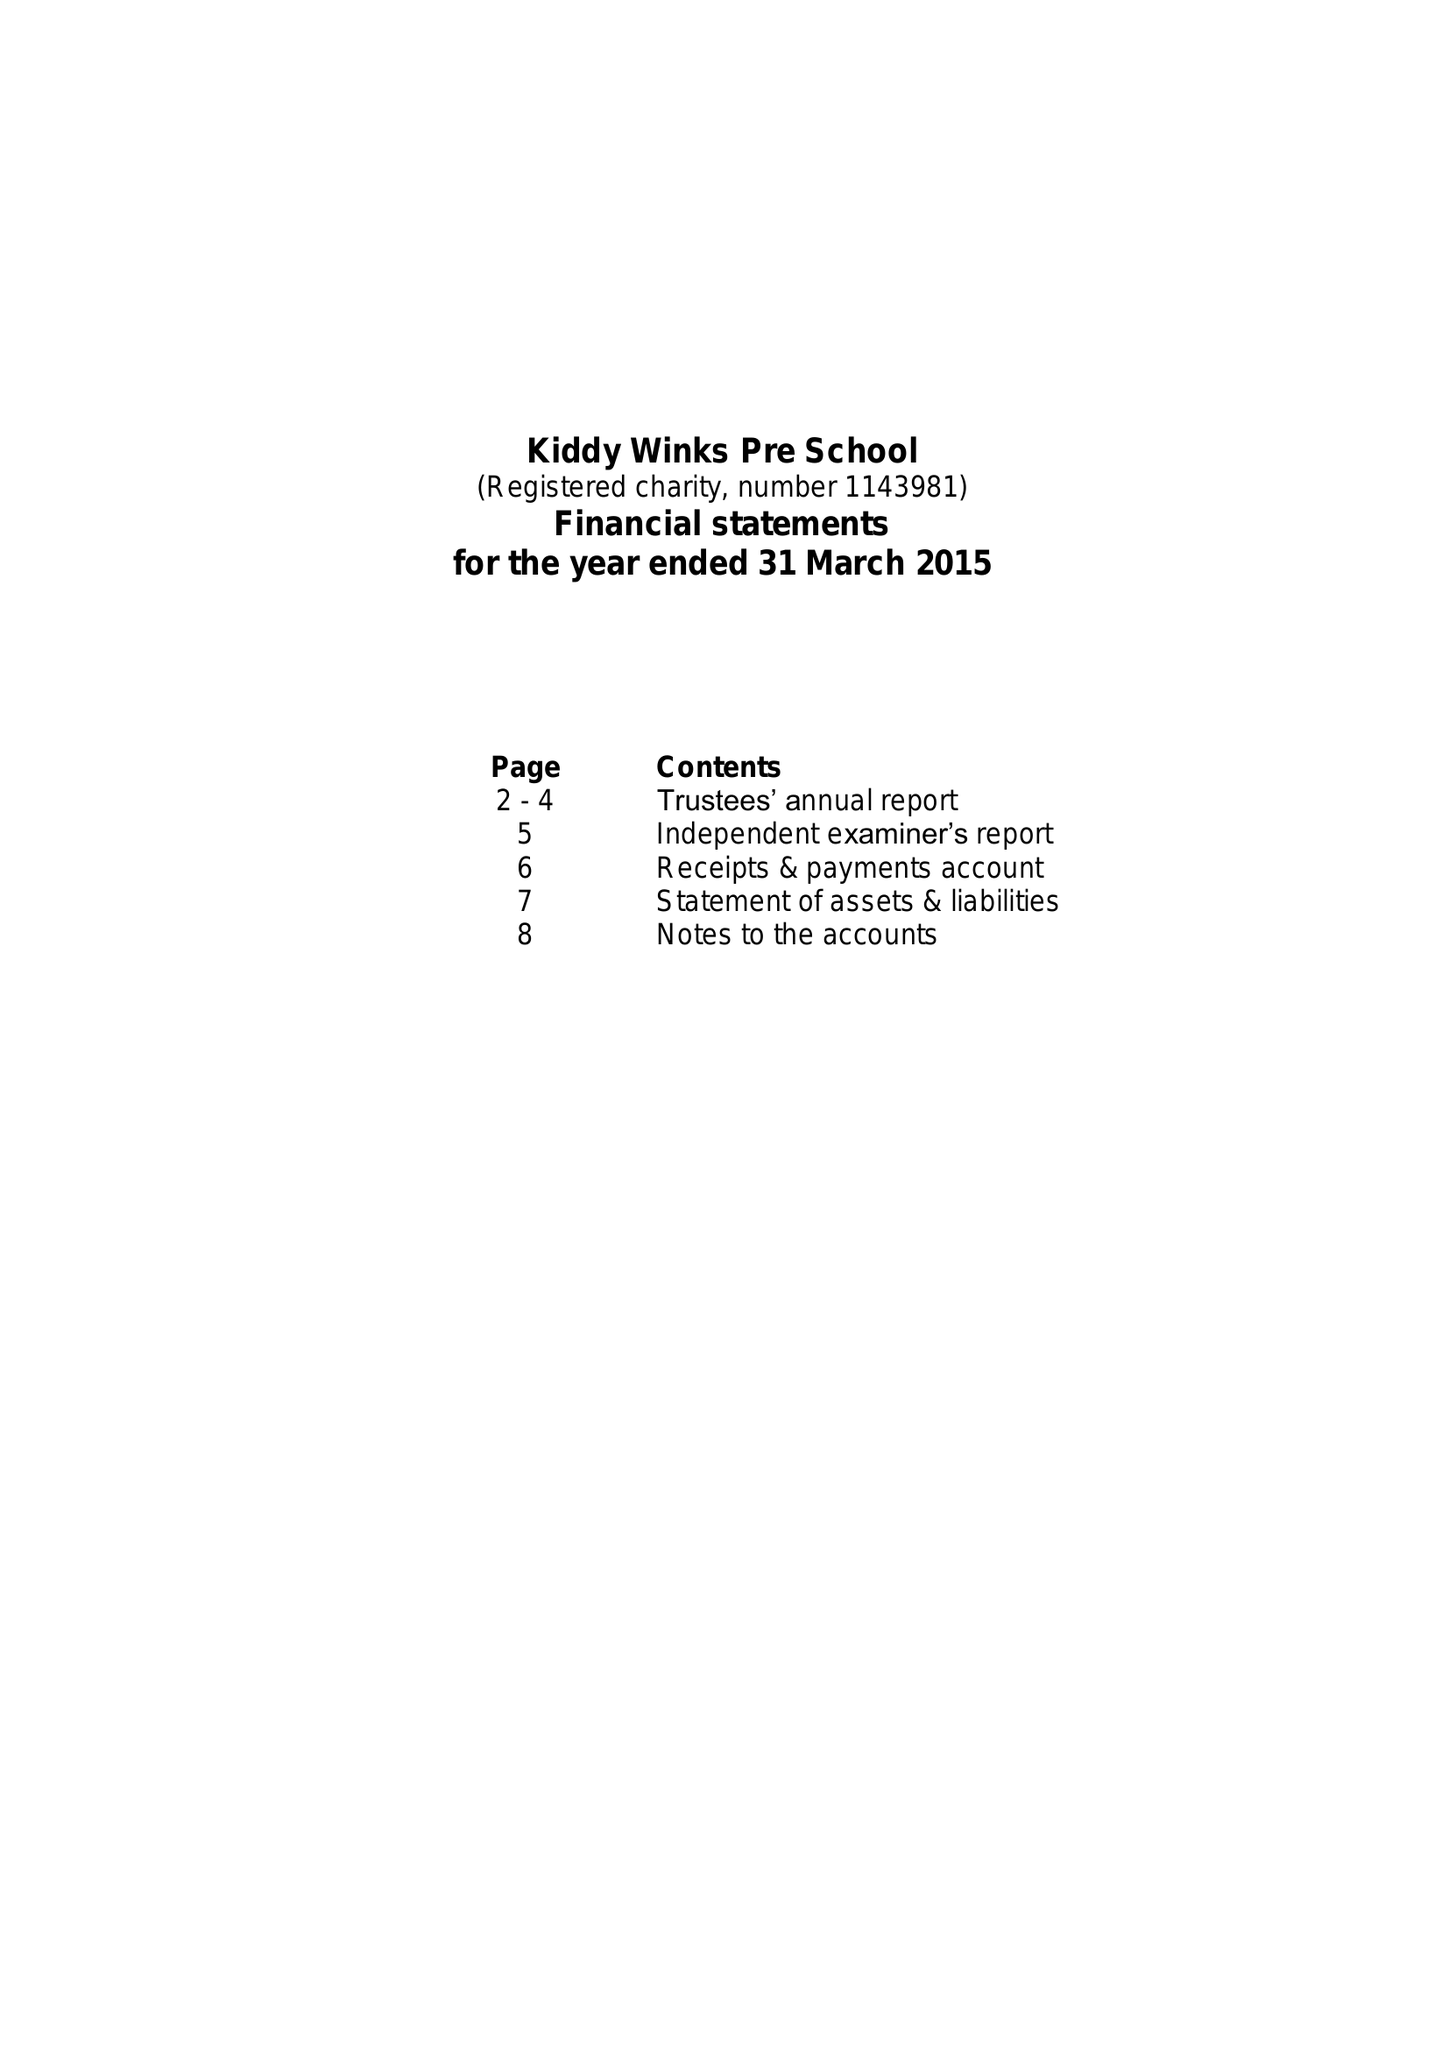What is the value for the charity_number?
Answer the question using a single word or phrase. 1143981 